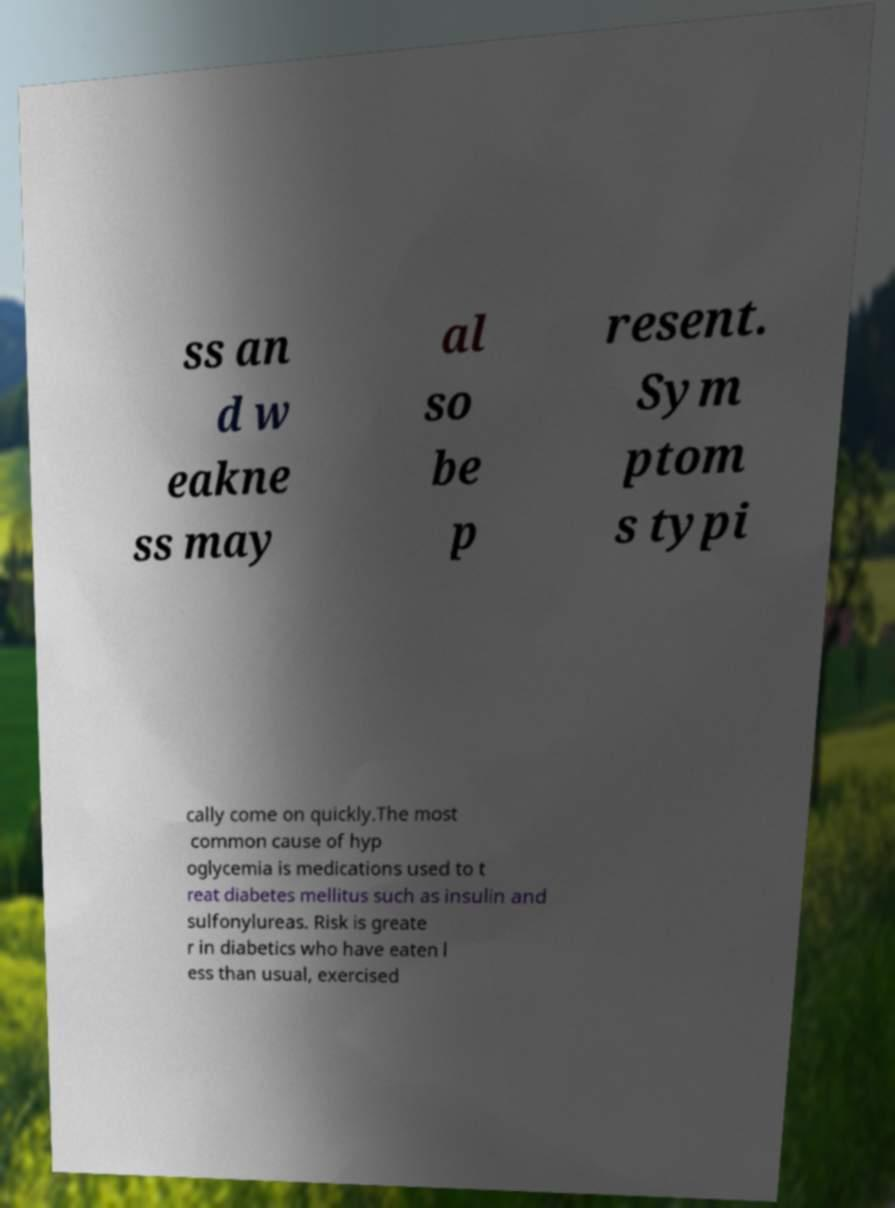Can you accurately transcribe the text from the provided image for me? ss an d w eakne ss may al so be p resent. Sym ptom s typi cally come on quickly.The most common cause of hyp oglycemia is medications used to t reat diabetes mellitus such as insulin and sulfonylureas. Risk is greate r in diabetics who have eaten l ess than usual, exercised 